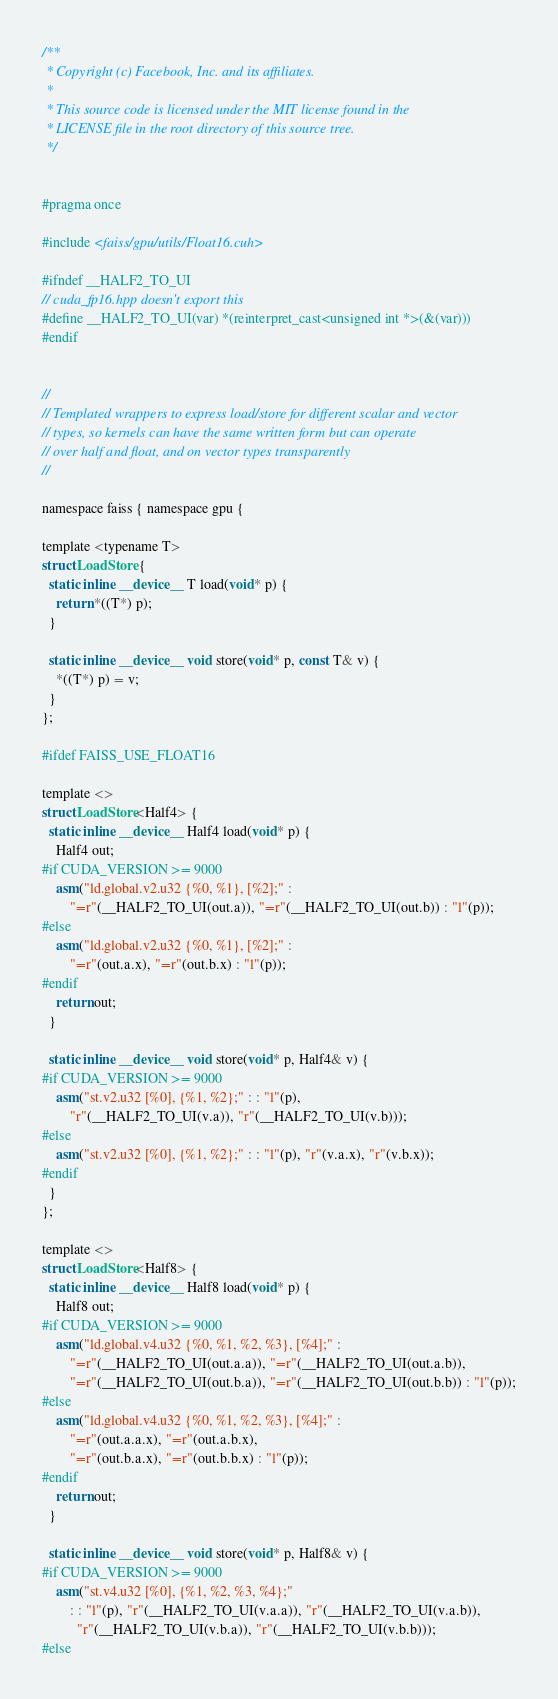<code> <loc_0><loc_0><loc_500><loc_500><_Cuda_>/**
 * Copyright (c) Facebook, Inc. and its affiliates.
 *
 * This source code is licensed under the MIT license found in the
 * LICENSE file in the root directory of this source tree.
 */


#pragma once

#include <faiss/gpu/utils/Float16.cuh>

#ifndef __HALF2_TO_UI
// cuda_fp16.hpp doesn't export this
#define __HALF2_TO_UI(var) *(reinterpret_cast<unsigned int *>(&(var)))
#endif


//
// Templated wrappers to express load/store for different scalar and vector
// types, so kernels can have the same written form but can operate
// over half and float, and on vector types transparently
//

namespace faiss { namespace gpu {

template <typename T>
struct LoadStore {
  static inline __device__ T load(void* p) {
    return *((T*) p);
  }

  static inline __device__ void store(void* p, const T& v) {
    *((T*) p) = v;
  }
};

#ifdef FAISS_USE_FLOAT16

template <>
struct LoadStore<Half4> {
  static inline __device__ Half4 load(void* p) {
    Half4 out;
#if CUDA_VERSION >= 9000
    asm("ld.global.v2.u32 {%0, %1}, [%2];" :
        "=r"(__HALF2_TO_UI(out.a)), "=r"(__HALF2_TO_UI(out.b)) : "l"(p));
#else
    asm("ld.global.v2.u32 {%0, %1}, [%2];" :
        "=r"(out.a.x), "=r"(out.b.x) : "l"(p));
#endif
    return out;
  }

  static inline __device__ void store(void* p, Half4& v) {
#if CUDA_VERSION >= 9000
    asm("st.v2.u32 [%0], {%1, %2};" : : "l"(p),
        "r"(__HALF2_TO_UI(v.a)), "r"(__HALF2_TO_UI(v.b)));
#else
    asm("st.v2.u32 [%0], {%1, %2};" : : "l"(p), "r"(v.a.x), "r"(v.b.x));
#endif
  }
};

template <>
struct LoadStore<Half8> {
  static inline __device__ Half8 load(void* p) {
    Half8 out;
#if CUDA_VERSION >= 9000
    asm("ld.global.v4.u32 {%0, %1, %2, %3}, [%4];" :
        "=r"(__HALF2_TO_UI(out.a.a)), "=r"(__HALF2_TO_UI(out.a.b)),
        "=r"(__HALF2_TO_UI(out.b.a)), "=r"(__HALF2_TO_UI(out.b.b)) : "l"(p));
#else
    asm("ld.global.v4.u32 {%0, %1, %2, %3}, [%4];" :
        "=r"(out.a.a.x), "=r"(out.a.b.x),
        "=r"(out.b.a.x), "=r"(out.b.b.x) : "l"(p));
#endif
    return out;
  }

  static inline __device__ void store(void* p, Half8& v) {
#if CUDA_VERSION >= 9000
    asm("st.v4.u32 [%0], {%1, %2, %3, %4};"
        : : "l"(p), "r"(__HALF2_TO_UI(v.a.a)), "r"(__HALF2_TO_UI(v.a.b)),
          "r"(__HALF2_TO_UI(v.b.a)), "r"(__HALF2_TO_UI(v.b.b)));
#else</code> 